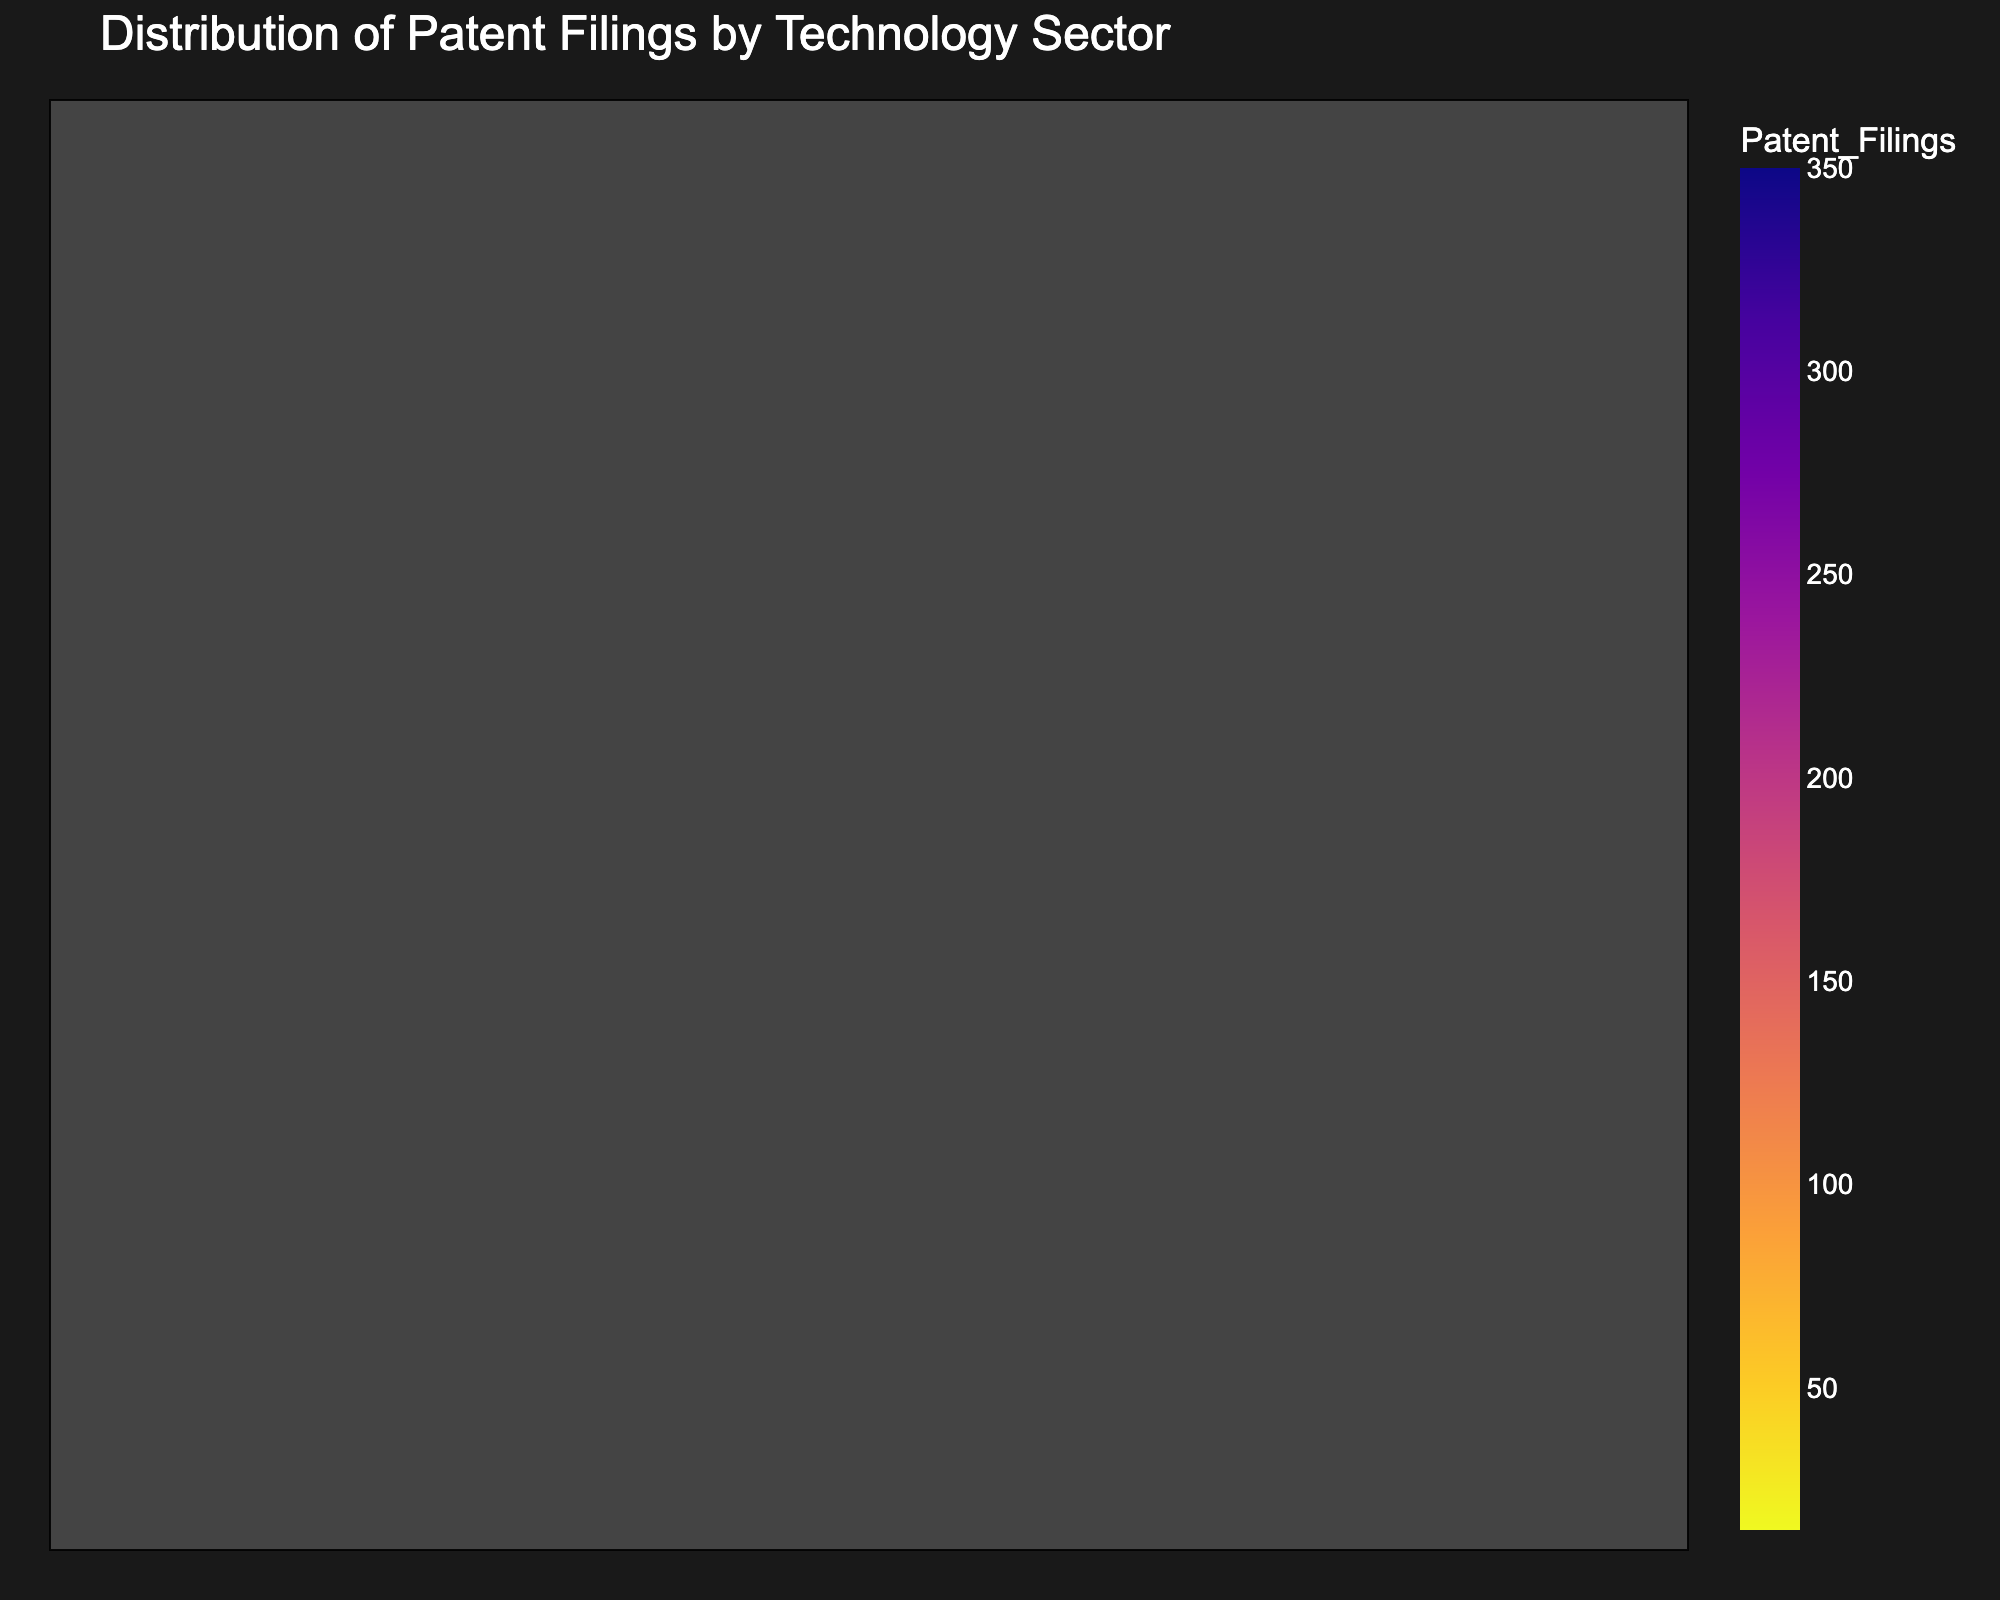How many technology sectors are represented in the Treemap? Count the number of unique sections in the Treemap to find the number of technology sectors.
Answer: 15 Which technology sector has the highest number of patent filings? Look at the largest section of the Treemap and read its label.
Answer: Electronics What is the total number of patent filings for Electronics and Software? Find the values for Electronics (350) and Software (280), then sum them up: 350 + 280 = 630
Answer: 630 What technology sector has more patent filings: Cybersecurity or Blockchain? Compare the sizes of the sections labeled Cybersecurity (90) and Blockchain (30). Cybersecurity has more.
Answer: Cybersecurity Which technology sectors have fewer than 50 patent filings? Locate sections with values less than 50. These are Augmented Reality (40), Blockchain (30), 5G Technology (25), Autonomous Vehicles (20), Biometrics (15).
Answer: Augmented Reality, Blockchain, 5G Technology, Autonomous Vehicles, Biometrics By how much does the number of patent filings for Artificial Intelligence exceed the number of filings for Quantum Computing? Calculate the difference between Artificial Intelligence (220) and Quantum Computing (60): 220 - 60 = 160
Answer: 160 What percentage of the total patent filings is accounted for by Semiconductors? Sum the total patent filings: 350+280+220+180+150+120+100+90+60+50+40+30+25+20+15 = 1730. Then, calculate the percentage for Semiconductors (150): (150/1730) * 100 ≈ 8.67%
Answer: 8.67% What is the average number of patent filings across all technology sectors? Sum the total patent filings (1730) and divide by the number of sectors (15): 1730 / 15 ≈ 115.33
Answer: 115.33 Which sector between Cloud Computing and Internet of Things has a higher number of patent filings, and by how much? Compare values for Cloud Computing (120) and Internet of Things (100). Cloud Computing has more by: 120 - 100 = 20
Answer: Cloud Computing; 20 Identify the three technology sectors with the lowest patent filings. Find the three smallest sections: Biometrics (15), Autonomous Vehicles (20), 5G Technology (25).
Answer: Biometrics, Autonomous Vehicles, 5G Technology 